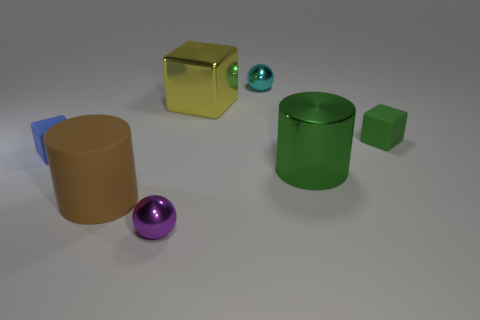What number of purple shiny spheres are on the right side of the metal sphere that is in front of the shiny sphere that is to the right of the metal block?
Keep it short and to the point. 0. What is the shape of the tiny purple shiny object?
Keep it short and to the point. Sphere. What number of other brown objects have the same material as the brown object?
Give a very brief answer. 0. What color is the block that is made of the same material as the tiny green object?
Provide a succinct answer. Blue. There is a purple shiny sphere; does it have the same size as the rubber cube on the left side of the green matte thing?
Offer a terse response. Yes. There is a ball behind the shiny ball that is in front of the small rubber object left of the yellow block; what is its material?
Offer a terse response. Metal. How many things are big yellow metal objects or tiny green rubber cylinders?
Keep it short and to the point. 1. Is the color of the tiny block on the right side of the blue rubber cube the same as the cylinder that is right of the tiny purple metal object?
Your answer should be very brief. Yes. The cyan metallic thing that is the same size as the purple shiny ball is what shape?
Your response must be concise. Sphere. What number of things are matte objects to the right of the large rubber cylinder or objects on the right side of the tiny blue cube?
Provide a succinct answer. 6. 